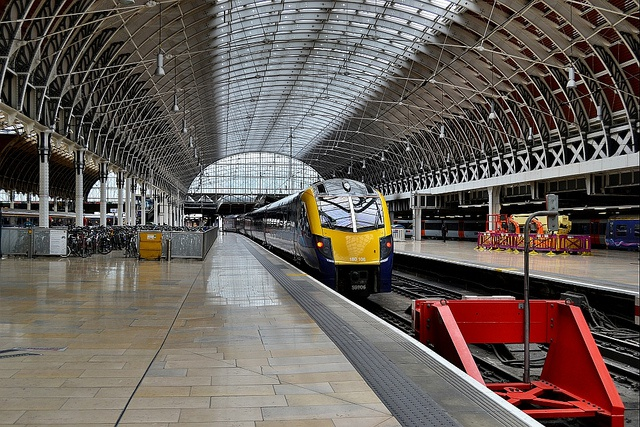Describe the objects in this image and their specific colors. I can see train in black, gray, orange, and darkgray tones, bicycle in black, gray, and darkgray tones, bicycle in black and gray tones, bicycle in black, gray, and darkgray tones, and bicycle in black, gray, and darkgray tones in this image. 